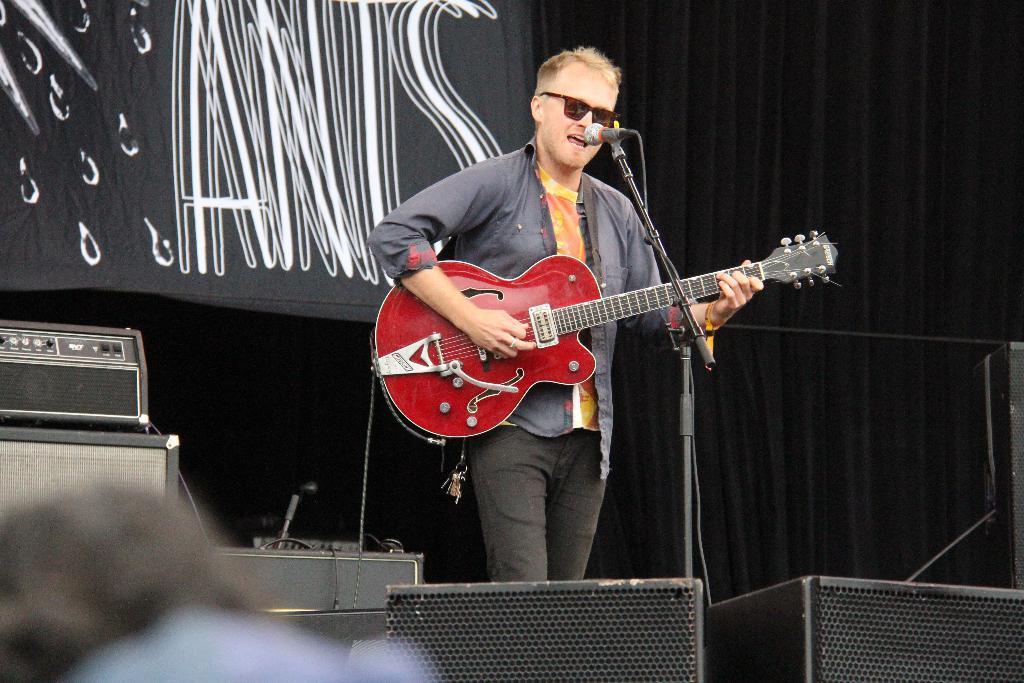In one or two sentences, can you explain what this image depicts? In this image there is a man standing. He is playing a guitar. In front of him there is a microphone. Behind him there is a curtain to the wall. To the left there are speakers and audio mixers. At the bottom there are boxes. 